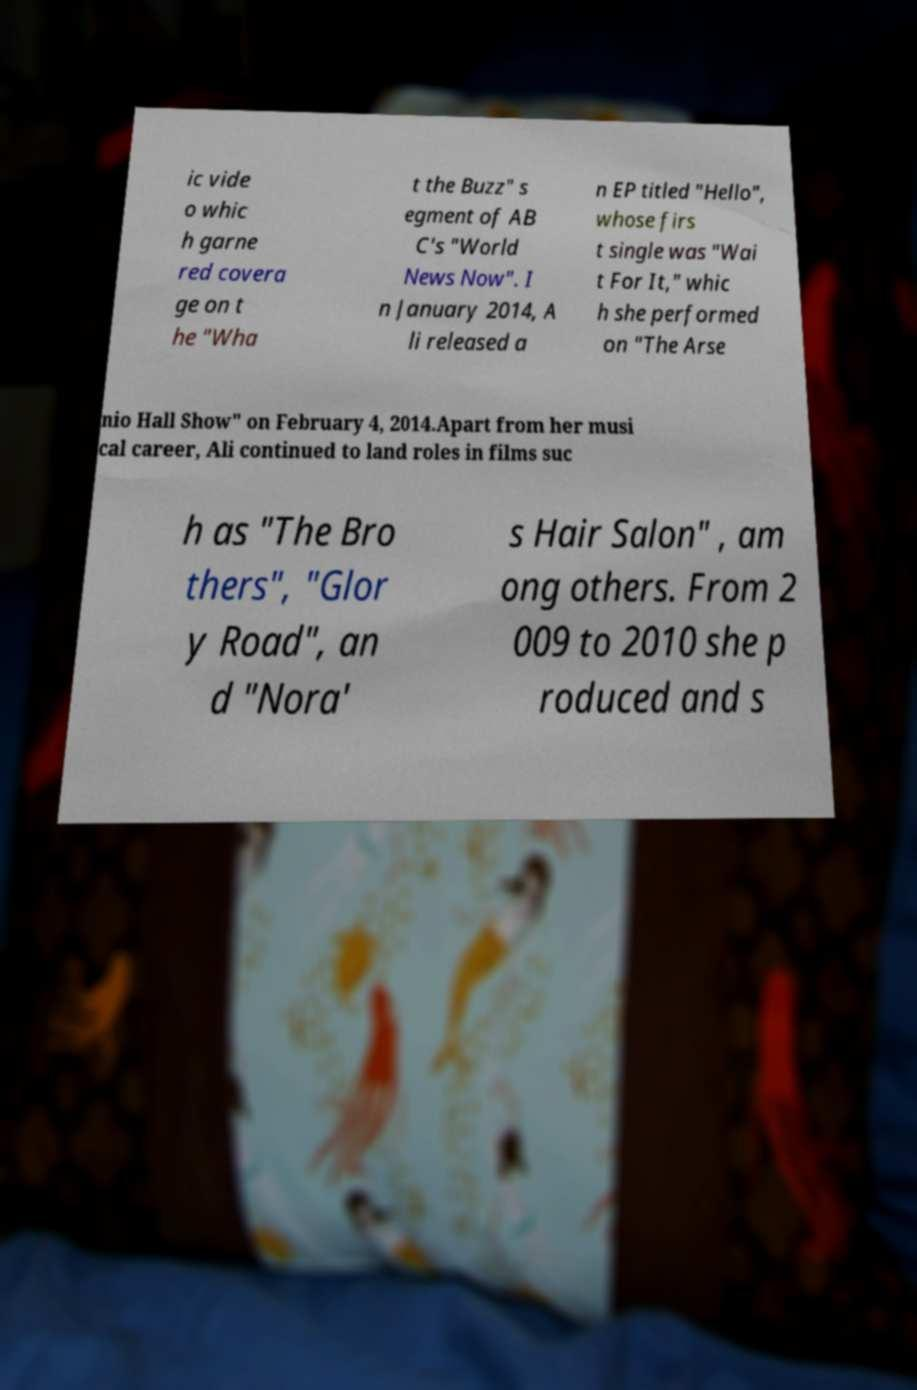For documentation purposes, I need the text within this image transcribed. Could you provide that? ic vide o whic h garne red covera ge on t he "Wha t the Buzz" s egment of AB C's "World News Now". I n January 2014, A li released a n EP titled "Hello", whose firs t single was "Wai t For It," whic h she performed on "The Arse nio Hall Show" on February 4, 2014.Apart from her musi cal career, Ali continued to land roles in films suc h as "The Bro thers", "Glor y Road", an d "Nora' s Hair Salon" , am ong others. From 2 009 to 2010 she p roduced and s 